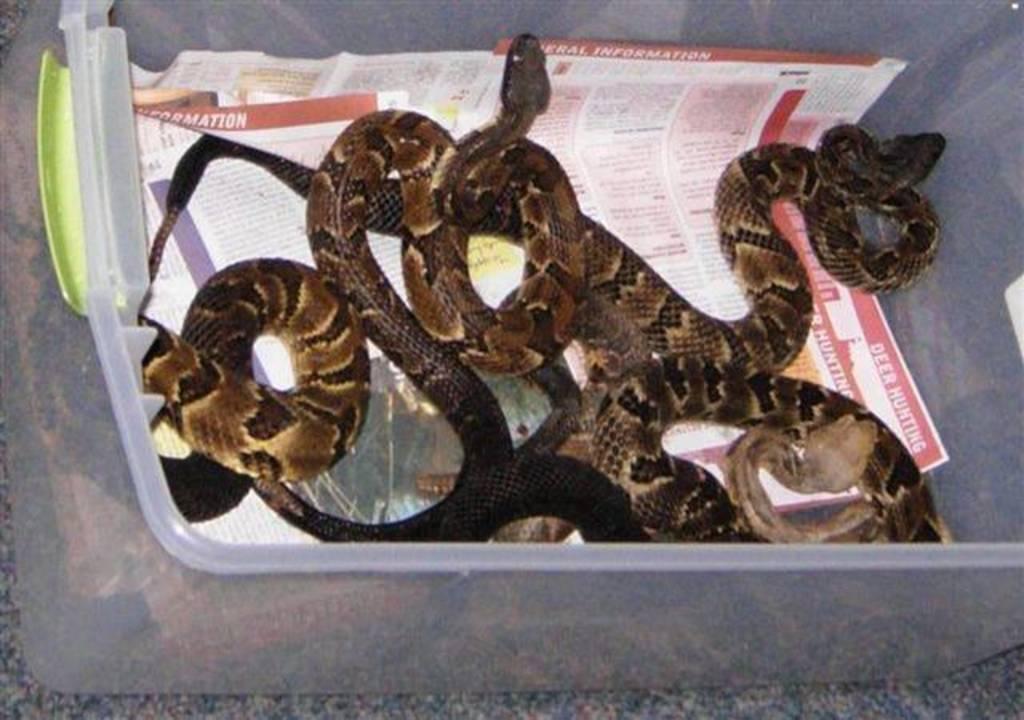Can you describe this image briefly? We can see snakes and papers in a box. 